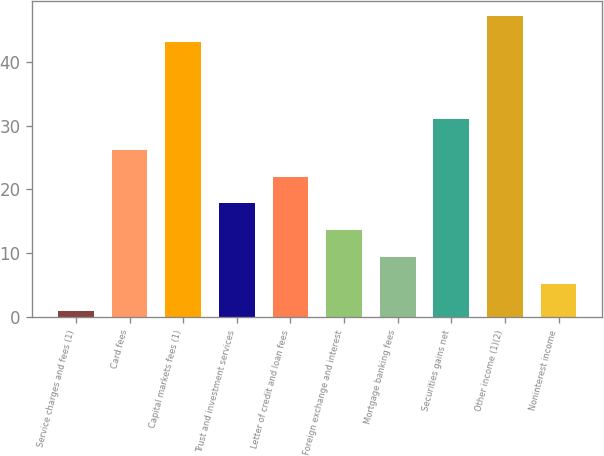<chart> <loc_0><loc_0><loc_500><loc_500><bar_chart><fcel>Service charges and fees (1)<fcel>Card fees<fcel>Capital markets fees (1)<fcel>Trust and investment services<fcel>Letter of credit and loan fees<fcel>Foreign exchange and interest<fcel>Mortgage banking fees<fcel>Securities gains net<fcel>Other income (1)(2)<fcel>Noninterest income<nl><fcel>1<fcel>26.2<fcel>43<fcel>17.8<fcel>22<fcel>13.6<fcel>9.4<fcel>31<fcel>47.2<fcel>5.2<nl></chart> 